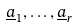<formula> <loc_0><loc_0><loc_500><loc_500>\underline { a } _ { 1 } , \dots , \underline { a } _ { r }</formula> 